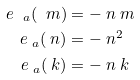<formula> <loc_0><loc_0><loc_500><loc_500>e _ { \ a } ( \ m ) & = - \ n \ m \\ e _ { \ a } ( \ n ) & = - \ n ^ { 2 } \\ e _ { \ a } ( \ k ) & = - \ n \ k</formula> 